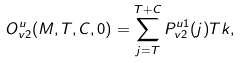Convert formula to latex. <formula><loc_0><loc_0><loc_500><loc_500>O _ { v 2 } ^ { u } ( M , T , C , 0 ) = \sum _ { j = T } ^ { T + C } P _ { v 2 } ^ { u 1 } ( j ) T k ,</formula> 